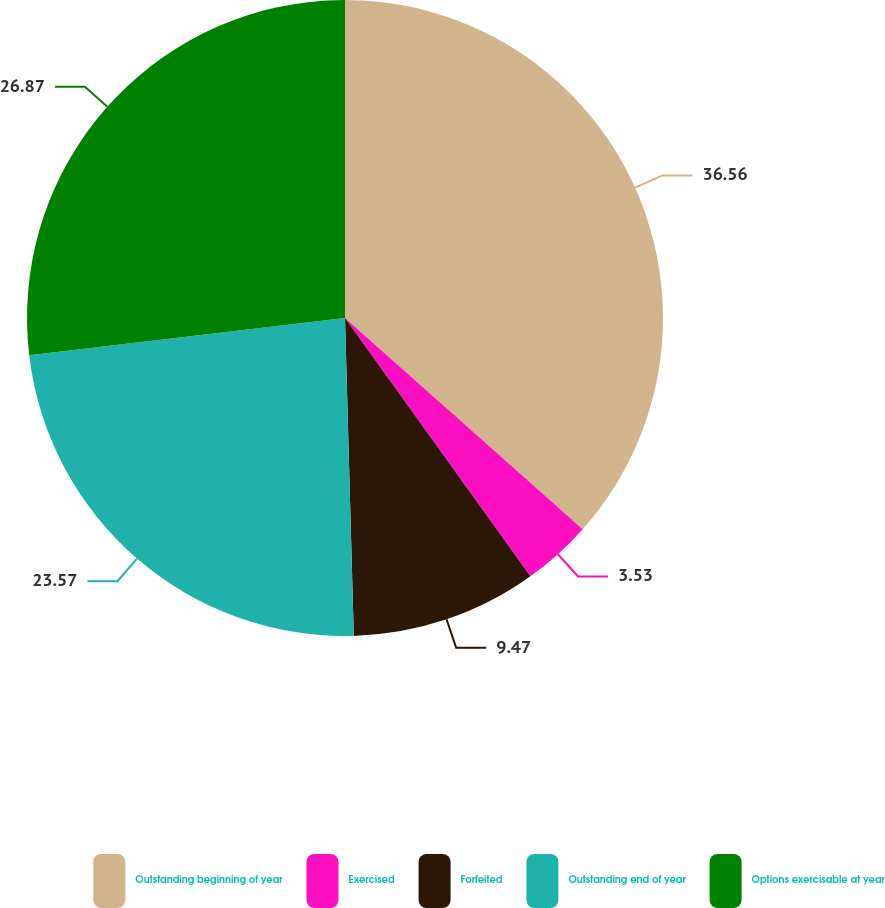Convert chart. <chart><loc_0><loc_0><loc_500><loc_500><pie_chart><fcel>Outstanding beginning of year<fcel>Exercised<fcel>Forfeited<fcel>Outstanding end of year<fcel>Options exercisable at year<nl><fcel>36.56%<fcel>3.53%<fcel>9.47%<fcel>23.57%<fcel>26.87%<nl></chart> 